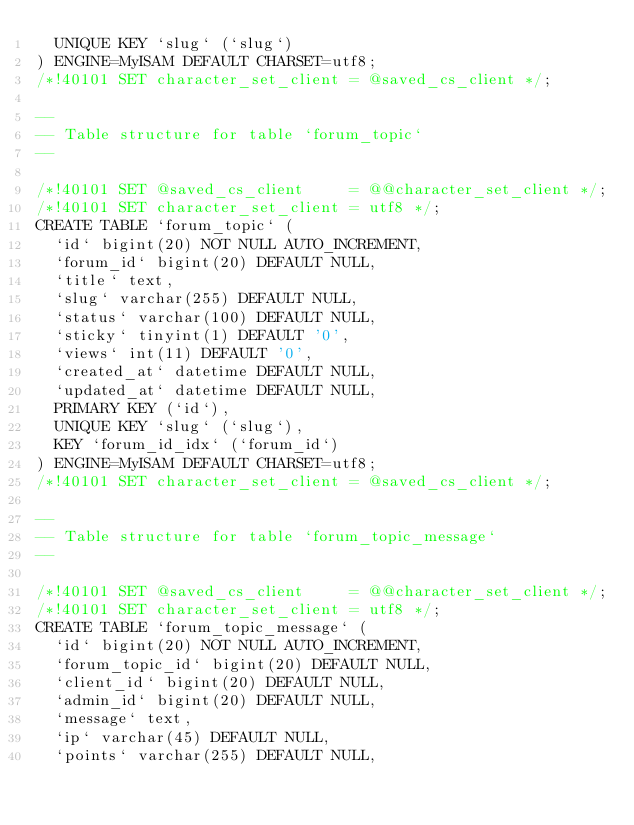<code> <loc_0><loc_0><loc_500><loc_500><_SQL_>  UNIQUE KEY `slug` (`slug`)
) ENGINE=MyISAM DEFAULT CHARSET=utf8;
/*!40101 SET character_set_client = @saved_cs_client */;

--
-- Table structure for table `forum_topic`
--

/*!40101 SET @saved_cs_client     = @@character_set_client */;
/*!40101 SET character_set_client = utf8 */;
CREATE TABLE `forum_topic` (
  `id` bigint(20) NOT NULL AUTO_INCREMENT,
  `forum_id` bigint(20) DEFAULT NULL,
  `title` text,
  `slug` varchar(255) DEFAULT NULL,
  `status` varchar(100) DEFAULT NULL,
  `sticky` tinyint(1) DEFAULT '0',
  `views` int(11) DEFAULT '0',
  `created_at` datetime DEFAULT NULL,
  `updated_at` datetime DEFAULT NULL,
  PRIMARY KEY (`id`),
  UNIQUE KEY `slug` (`slug`),
  KEY `forum_id_idx` (`forum_id`)
) ENGINE=MyISAM DEFAULT CHARSET=utf8;
/*!40101 SET character_set_client = @saved_cs_client */;

--
-- Table structure for table `forum_topic_message`
--

/*!40101 SET @saved_cs_client     = @@character_set_client */;
/*!40101 SET character_set_client = utf8 */;
CREATE TABLE `forum_topic_message` (
  `id` bigint(20) NOT NULL AUTO_INCREMENT,
  `forum_topic_id` bigint(20) DEFAULT NULL,
  `client_id` bigint(20) DEFAULT NULL,
  `admin_id` bigint(20) DEFAULT NULL,
  `message` text,
  `ip` varchar(45) DEFAULT NULL,
  `points` varchar(255) DEFAULT NULL,</code> 